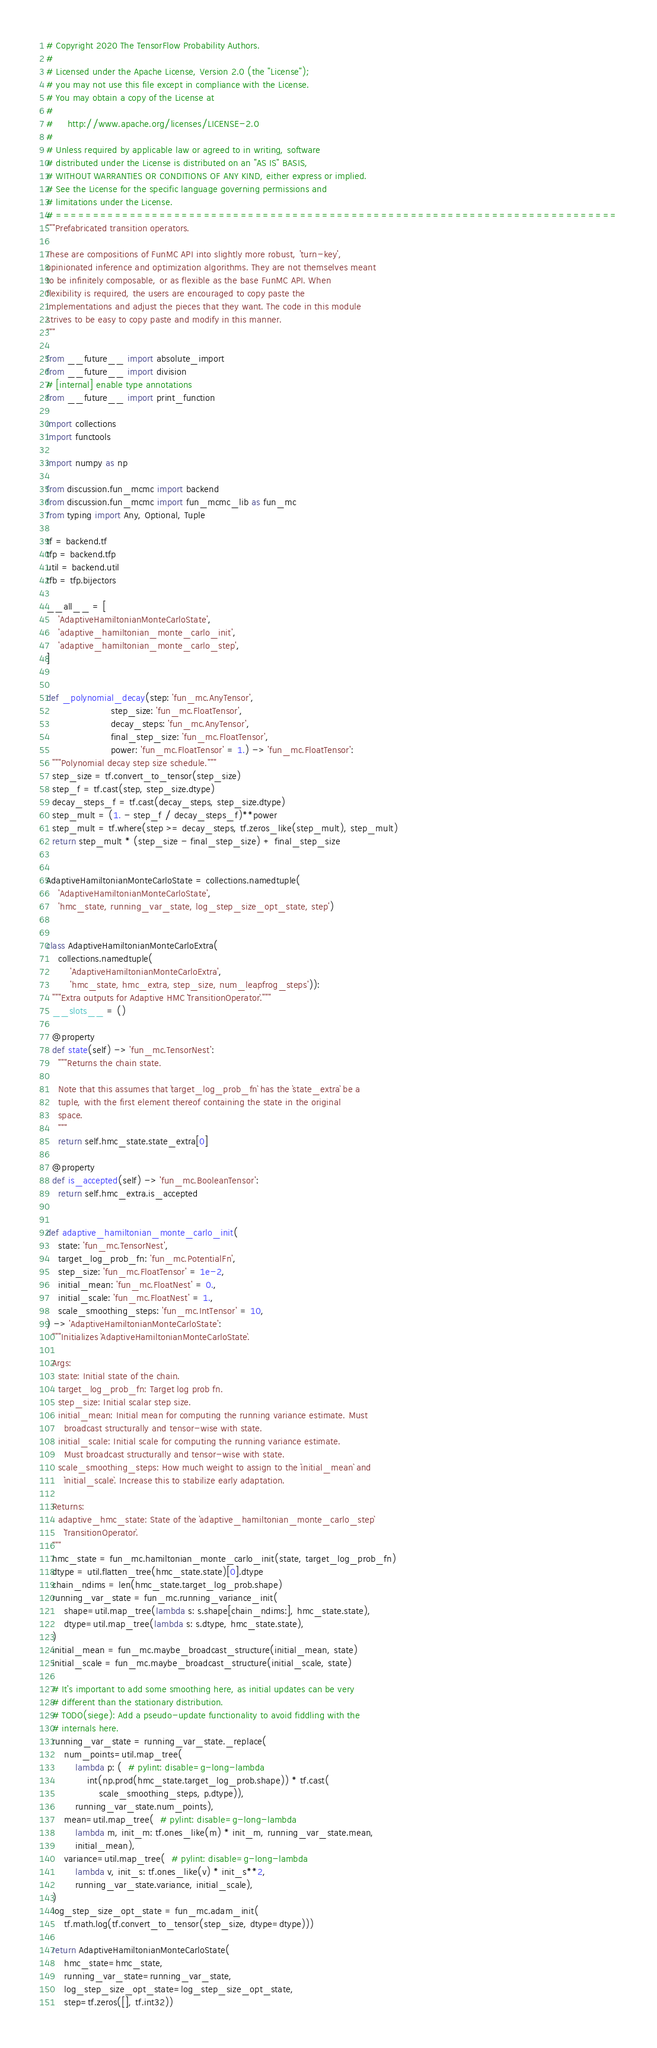Convert code to text. <code><loc_0><loc_0><loc_500><loc_500><_Python_># Copyright 2020 The TensorFlow Probability Authors.
#
# Licensed under the Apache License, Version 2.0 (the "License");
# you may not use this file except in compliance with the License.
# You may obtain a copy of the License at
#
#     http://www.apache.org/licenses/LICENSE-2.0
#
# Unless required by applicable law or agreed to in writing, software
# distributed under the License is distributed on an "AS IS" BASIS,
# WITHOUT WARRANTIES OR CONDITIONS OF ANY KIND, either express or implied.
# See the License for the specific language governing permissions and
# limitations under the License.
# ============================================================================
"""Prefabricated transition operators.

These are compositions of FunMC API into slightly more robust, 'turn-key',
opinionated inference and optimization algorithms. They are not themselves meant
to be infinitely composable, or as flexible as the base FunMC API. When
flexibility is required, the users are encouraged to copy paste the
implementations and adjust the pieces that they want. The code in this module
strives to be easy to copy paste and modify in this manner.
"""

from __future__ import absolute_import
from __future__ import division
# [internal] enable type annotations
from __future__ import print_function

import collections
import functools

import numpy as np

from discussion.fun_mcmc import backend
from discussion.fun_mcmc import fun_mcmc_lib as fun_mc
from typing import Any, Optional, Tuple

tf = backend.tf
tfp = backend.tfp
util = backend.util
tfb = tfp.bijectors

__all__ = [
    'AdaptiveHamiltonianMonteCarloState',
    'adaptive_hamiltonian_monte_carlo_init',
    'adaptive_hamiltonian_monte_carlo_step',
]


def _polynomial_decay(step: 'fun_mc.AnyTensor',
                      step_size: 'fun_mc.FloatTensor',
                      decay_steps: 'fun_mc.AnyTensor',
                      final_step_size: 'fun_mc.FloatTensor',
                      power: 'fun_mc.FloatTensor' = 1.) -> 'fun_mc.FloatTensor':
  """Polynomial decay step size schedule."""
  step_size = tf.convert_to_tensor(step_size)
  step_f = tf.cast(step, step_size.dtype)
  decay_steps_f = tf.cast(decay_steps, step_size.dtype)
  step_mult = (1. - step_f / decay_steps_f)**power
  step_mult = tf.where(step >= decay_steps, tf.zeros_like(step_mult), step_mult)
  return step_mult * (step_size - final_step_size) + final_step_size


AdaptiveHamiltonianMonteCarloState = collections.namedtuple(
    'AdaptiveHamiltonianMonteCarloState',
    'hmc_state, running_var_state, log_step_size_opt_state, step')


class AdaptiveHamiltonianMonteCarloExtra(
    collections.namedtuple(
        'AdaptiveHamiltonianMonteCarloExtra',
        'hmc_state, hmc_extra, step_size, num_leapfrog_steps')):
  """Extra outputs for Adaptive HMC `TransitionOperator`."""
  __slots__ = ()

  @property
  def state(self) -> 'fun_mc.TensorNest':
    """Returns the chain state.

    Note that this assumes that `target_log_prob_fn` has the `state_extra` be a
    tuple, with the first element thereof containing the state in the original
    space.
    """
    return self.hmc_state.state_extra[0]

  @property
  def is_accepted(self) -> 'fun_mc.BooleanTensor':
    return self.hmc_extra.is_accepted


def adaptive_hamiltonian_monte_carlo_init(
    state: 'fun_mc.TensorNest',
    target_log_prob_fn: 'fun_mc.PotentialFn',
    step_size: 'fun_mc.FloatTensor' = 1e-2,
    initial_mean: 'fun_mc.FloatNest' = 0.,
    initial_scale: 'fun_mc.FloatNest' = 1.,
    scale_smoothing_steps: 'fun_mc.IntTensor' = 10,
) -> 'AdaptiveHamiltonianMonteCarloState':
  """Initializes `AdaptiveHamiltonianMonteCarloState`.

  Args:
    state: Initial state of the chain.
    target_log_prob_fn: Target log prob fn.
    step_size: Initial scalar step size.
    initial_mean: Initial mean for computing the running variance estimate. Must
      broadcast structurally and tensor-wise with state.
    initial_scale: Initial scale for computing the running variance estimate.
      Must broadcast structurally and tensor-wise with state.
    scale_smoothing_steps: How much weight to assign to the `initial_mean` and
      `initial_scale`. Increase this to stabilize early adaptation.

  Returns:
    adaptive_hmc_state: State of the `adaptive_hamiltonian_monte_carlo_step`
      `TransitionOperator`.
  """
  hmc_state = fun_mc.hamiltonian_monte_carlo_init(state, target_log_prob_fn)
  dtype = util.flatten_tree(hmc_state.state)[0].dtype
  chain_ndims = len(hmc_state.target_log_prob.shape)
  running_var_state = fun_mc.running_variance_init(
      shape=util.map_tree(lambda s: s.shape[chain_ndims:], hmc_state.state),
      dtype=util.map_tree(lambda s: s.dtype, hmc_state.state),
  )
  initial_mean = fun_mc.maybe_broadcast_structure(initial_mean, state)
  initial_scale = fun_mc.maybe_broadcast_structure(initial_scale, state)

  # It's important to add some smoothing here, as initial updates can be very
  # different than the stationary distribution.
  # TODO(siege): Add a pseudo-update functionality to avoid fiddling with the
  # internals here.
  running_var_state = running_var_state._replace(
      num_points=util.map_tree(
          lambda p: (  # pylint: disable=g-long-lambda
              int(np.prod(hmc_state.target_log_prob.shape)) * tf.cast(
                  scale_smoothing_steps, p.dtype)),
          running_var_state.num_points),
      mean=util.map_tree(  # pylint: disable=g-long-lambda
          lambda m, init_m: tf.ones_like(m) * init_m, running_var_state.mean,
          initial_mean),
      variance=util.map_tree(  # pylint: disable=g-long-lambda
          lambda v, init_s: tf.ones_like(v) * init_s**2,
          running_var_state.variance, initial_scale),
  )
  log_step_size_opt_state = fun_mc.adam_init(
      tf.math.log(tf.convert_to_tensor(step_size, dtype=dtype)))

  return AdaptiveHamiltonianMonteCarloState(
      hmc_state=hmc_state,
      running_var_state=running_var_state,
      log_step_size_opt_state=log_step_size_opt_state,
      step=tf.zeros([], tf.int32))

</code> 